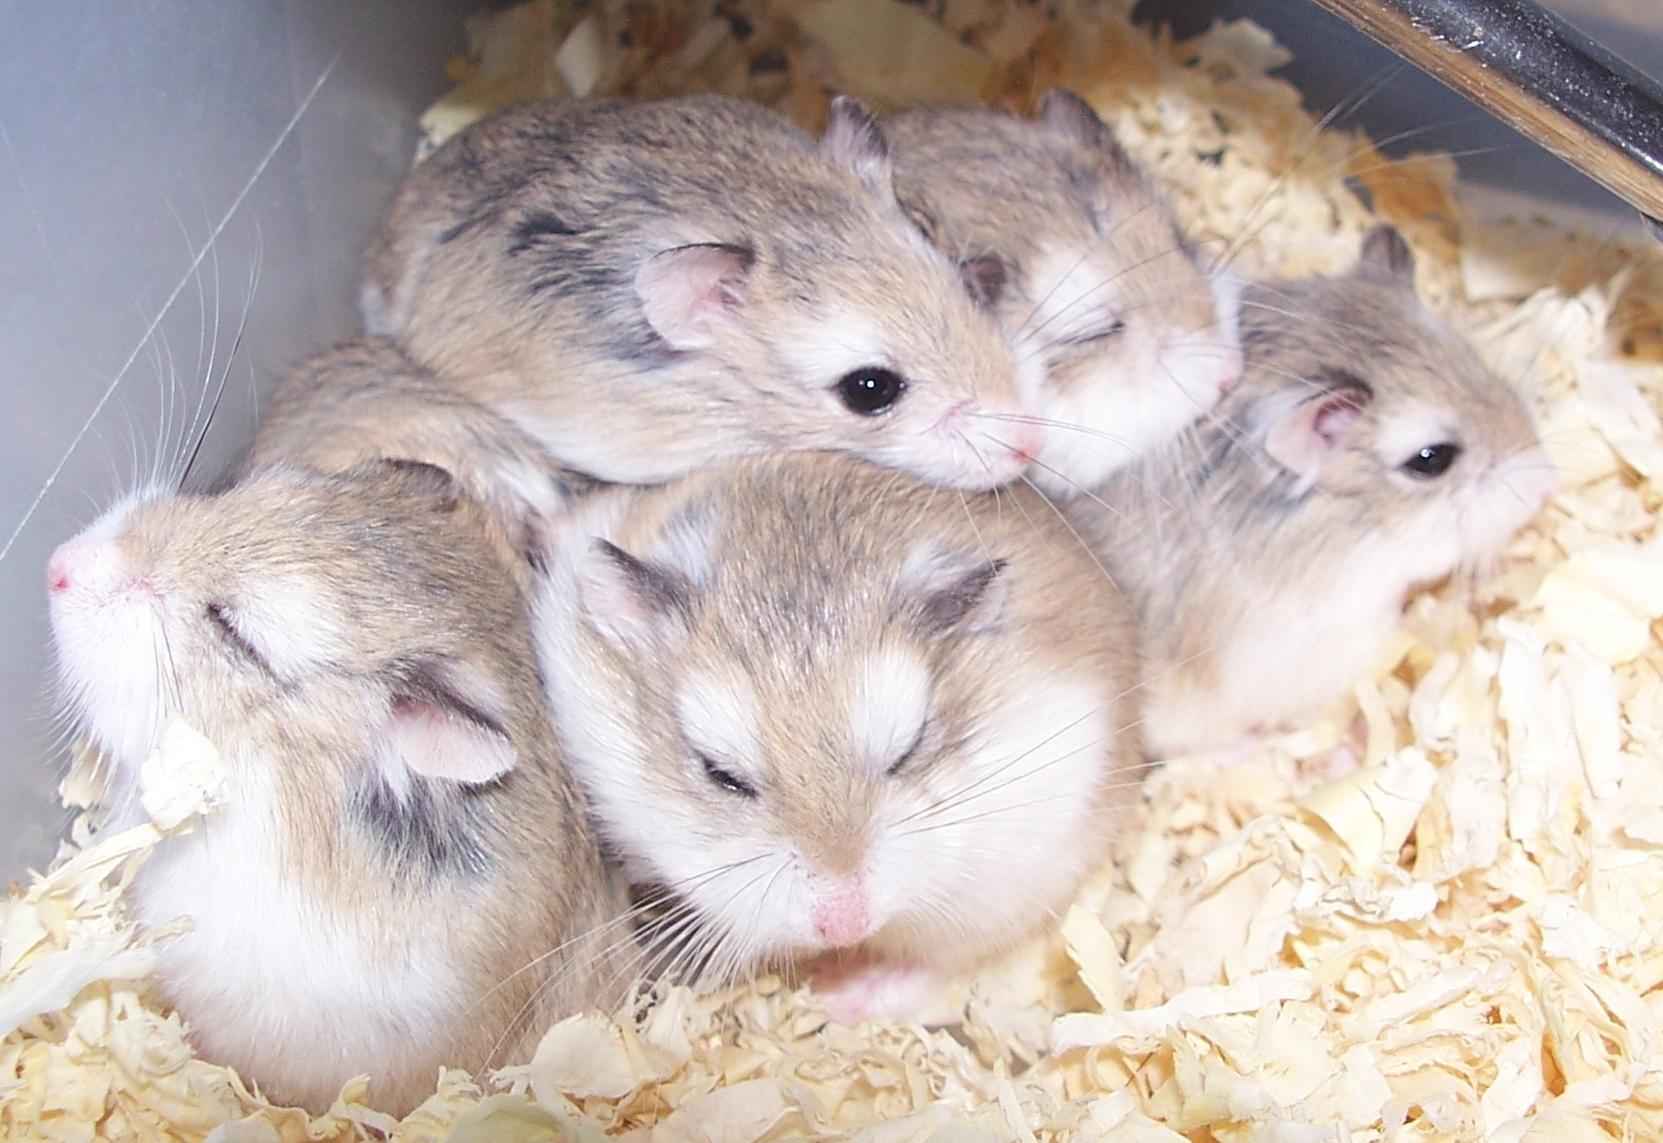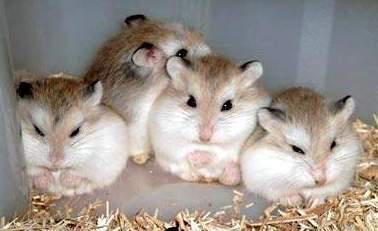The first image is the image on the left, the second image is the image on the right. Evaluate the accuracy of this statement regarding the images: "There are more hamsters in the image on the right than on the left.". Is it true? Answer yes or no. No. 